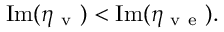<formula> <loc_0><loc_0><loc_500><loc_500>I m ( \eta _ { v } ) < I m ( \eta _ { v e } ) .</formula> 